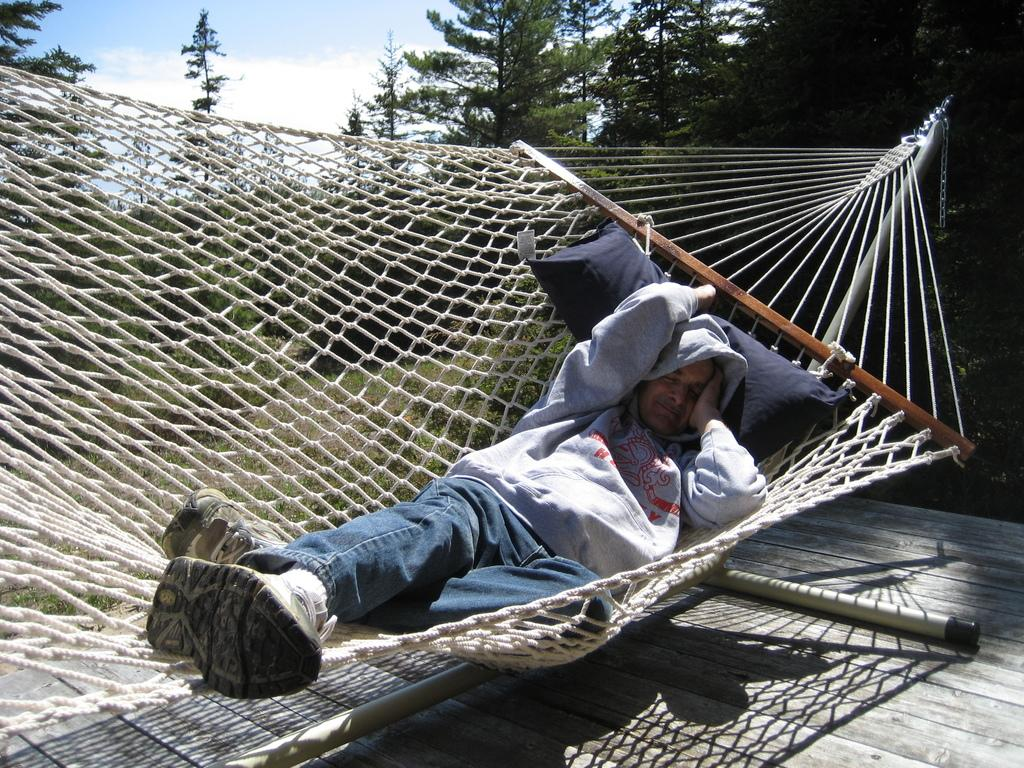What is the person in the image doing? The person is sleeping on a hammock. What is supporting the person's head while they sleep? There is a pillow in the image. What can be seen in the background of the image? There are trees at the back. What is the rate of the treatment being administered to the person in the image? There is no treatment being administered to the person in the image; they are simply sleeping on a hammock. What color is the person's lip in the image? The provided facts do not mention the color of the person's lip, and it cannot be determined from the image. 